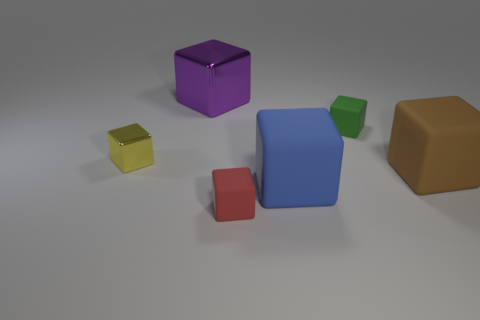Subtract all purple cubes. How many cubes are left? 5 Subtract all brown cubes. How many cubes are left? 5 Subtract all gray cubes. Subtract all blue spheres. How many cubes are left? 6 Add 3 large red metal cylinders. How many objects exist? 9 Add 5 tiny things. How many tiny things exist? 8 Subtract 0 cyan cylinders. How many objects are left? 6 Subtract all yellow objects. Subtract all large purple metal cubes. How many objects are left? 4 Add 5 green rubber objects. How many green rubber objects are left? 6 